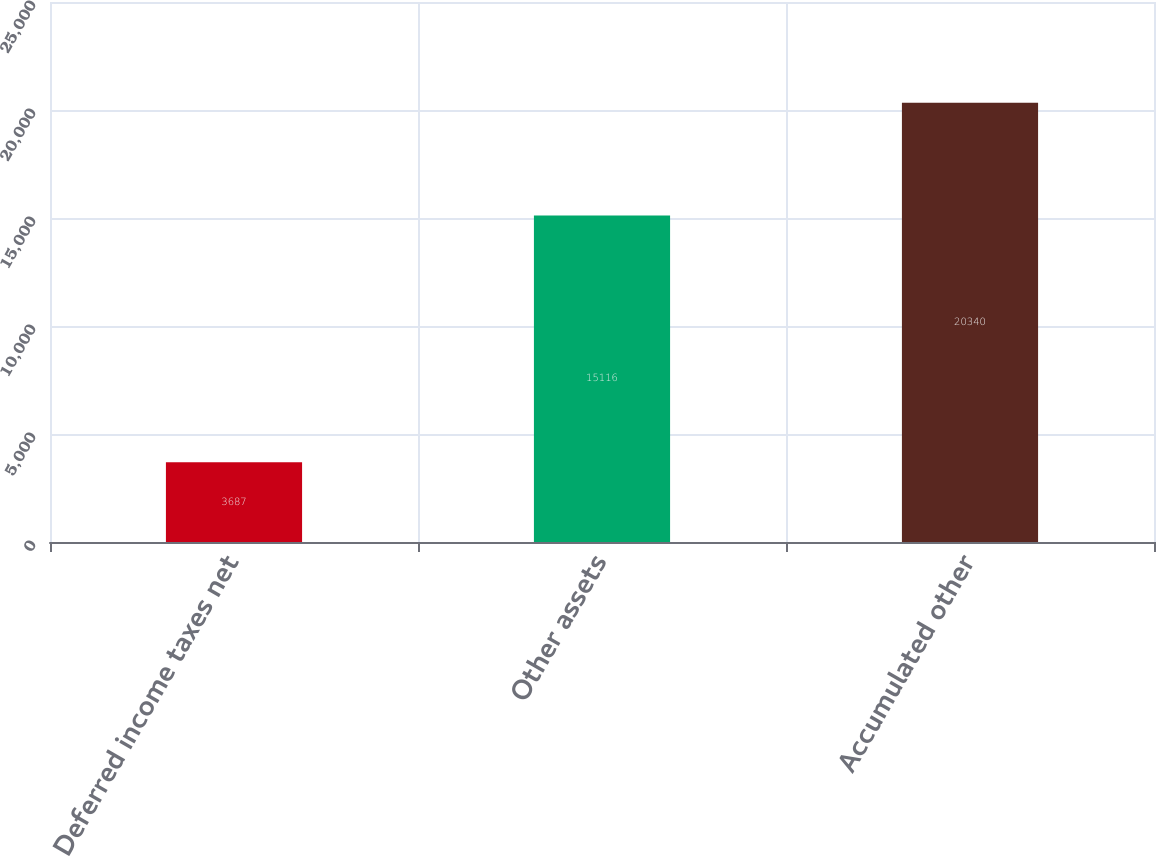Convert chart. <chart><loc_0><loc_0><loc_500><loc_500><bar_chart><fcel>Deferred income taxes net<fcel>Other assets<fcel>Accumulated other<nl><fcel>3687<fcel>15116<fcel>20340<nl></chart> 